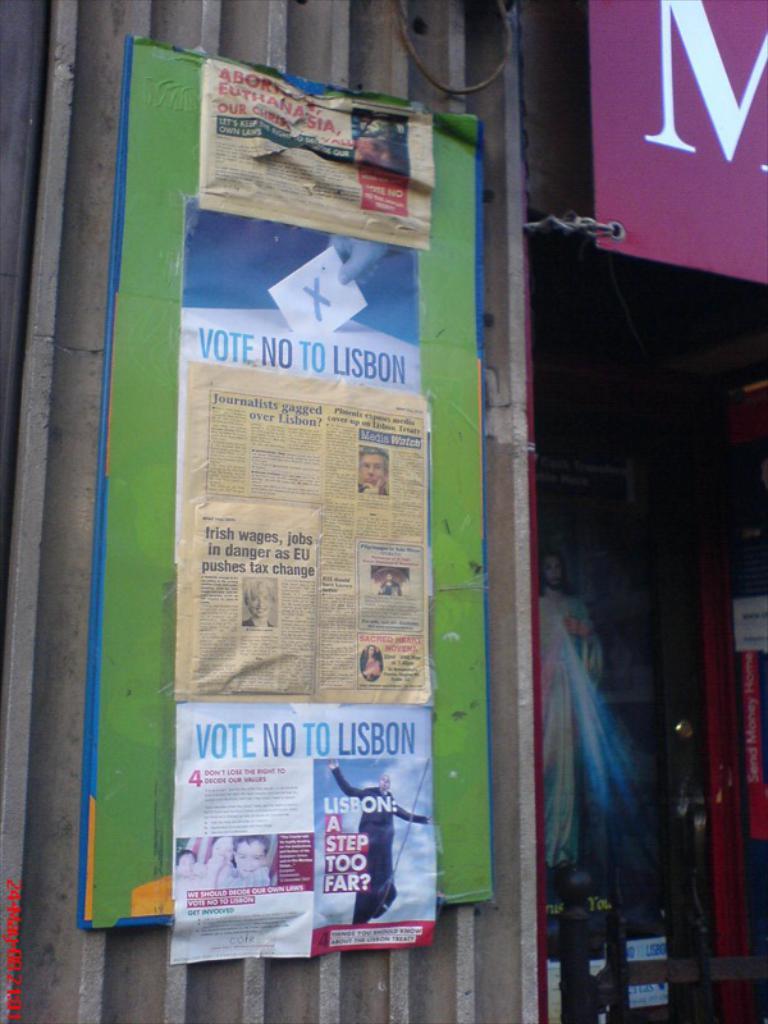What is the ad telling you to do?
Offer a very short reply. Vote no to lisbon. 